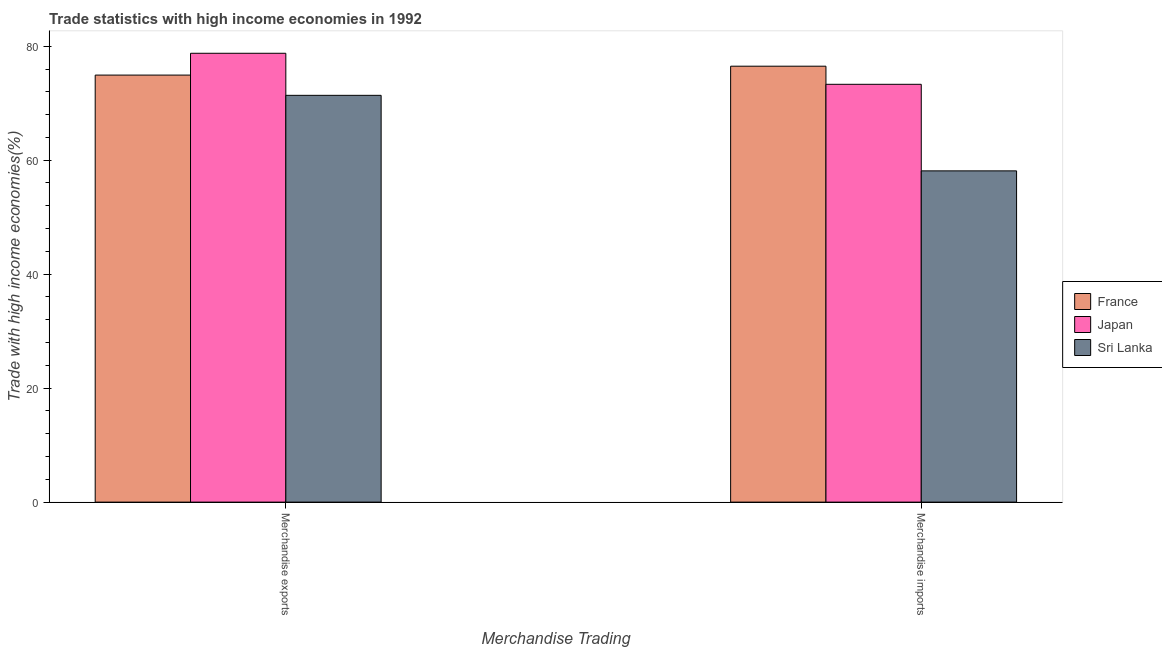How many groups of bars are there?
Offer a terse response. 2. Are the number of bars per tick equal to the number of legend labels?
Offer a very short reply. Yes. Are the number of bars on each tick of the X-axis equal?
Make the answer very short. Yes. How many bars are there on the 2nd tick from the left?
Provide a succinct answer. 3. How many bars are there on the 2nd tick from the right?
Provide a succinct answer. 3. What is the merchandise imports in France?
Provide a succinct answer. 76.49. Across all countries, what is the maximum merchandise exports?
Offer a terse response. 78.76. Across all countries, what is the minimum merchandise imports?
Your response must be concise. 58.13. In which country was the merchandise exports maximum?
Provide a short and direct response. Japan. In which country was the merchandise imports minimum?
Provide a short and direct response. Sri Lanka. What is the total merchandise exports in the graph?
Your response must be concise. 225.07. What is the difference between the merchandise imports in Japan and that in France?
Your answer should be compact. -3.18. What is the difference between the merchandise imports in Sri Lanka and the merchandise exports in France?
Give a very brief answer. -16.81. What is the average merchandise imports per country?
Provide a short and direct response. 69.31. What is the difference between the merchandise exports and merchandise imports in France?
Offer a terse response. -1.56. What is the ratio of the merchandise exports in Sri Lanka to that in France?
Your answer should be very brief. 0.95. Is the merchandise imports in France less than that in Japan?
Your answer should be very brief. No. What does the 3rd bar from the left in Merchandise imports represents?
Ensure brevity in your answer.  Sri Lanka. What does the 3rd bar from the right in Merchandise exports represents?
Keep it short and to the point. France. Are the values on the major ticks of Y-axis written in scientific E-notation?
Offer a very short reply. No. How many legend labels are there?
Provide a succinct answer. 3. What is the title of the graph?
Provide a succinct answer. Trade statistics with high income economies in 1992. What is the label or title of the X-axis?
Keep it short and to the point. Merchandise Trading. What is the label or title of the Y-axis?
Offer a terse response. Trade with high income economies(%). What is the Trade with high income economies(%) of France in Merchandise exports?
Keep it short and to the point. 74.93. What is the Trade with high income economies(%) of Japan in Merchandise exports?
Provide a succinct answer. 78.76. What is the Trade with high income economies(%) in Sri Lanka in Merchandise exports?
Give a very brief answer. 71.38. What is the Trade with high income economies(%) in France in Merchandise imports?
Provide a succinct answer. 76.49. What is the Trade with high income economies(%) of Japan in Merchandise imports?
Keep it short and to the point. 73.31. What is the Trade with high income economies(%) in Sri Lanka in Merchandise imports?
Offer a terse response. 58.13. Across all Merchandise Trading, what is the maximum Trade with high income economies(%) of France?
Make the answer very short. 76.49. Across all Merchandise Trading, what is the maximum Trade with high income economies(%) in Japan?
Provide a short and direct response. 78.76. Across all Merchandise Trading, what is the maximum Trade with high income economies(%) of Sri Lanka?
Provide a succinct answer. 71.38. Across all Merchandise Trading, what is the minimum Trade with high income economies(%) of France?
Provide a succinct answer. 74.93. Across all Merchandise Trading, what is the minimum Trade with high income economies(%) in Japan?
Make the answer very short. 73.31. Across all Merchandise Trading, what is the minimum Trade with high income economies(%) of Sri Lanka?
Keep it short and to the point. 58.13. What is the total Trade with high income economies(%) of France in the graph?
Your answer should be compact. 151.42. What is the total Trade with high income economies(%) of Japan in the graph?
Keep it short and to the point. 152.07. What is the total Trade with high income economies(%) of Sri Lanka in the graph?
Give a very brief answer. 129.5. What is the difference between the Trade with high income economies(%) of France in Merchandise exports and that in Merchandise imports?
Your answer should be very brief. -1.56. What is the difference between the Trade with high income economies(%) of Japan in Merchandise exports and that in Merchandise imports?
Ensure brevity in your answer.  5.45. What is the difference between the Trade with high income economies(%) in Sri Lanka in Merchandise exports and that in Merchandise imports?
Keep it short and to the point. 13.25. What is the difference between the Trade with high income economies(%) in France in Merchandise exports and the Trade with high income economies(%) in Japan in Merchandise imports?
Provide a short and direct response. 1.62. What is the difference between the Trade with high income economies(%) in France in Merchandise exports and the Trade with high income economies(%) in Sri Lanka in Merchandise imports?
Give a very brief answer. 16.81. What is the difference between the Trade with high income economies(%) in Japan in Merchandise exports and the Trade with high income economies(%) in Sri Lanka in Merchandise imports?
Provide a succinct answer. 20.64. What is the average Trade with high income economies(%) of France per Merchandise Trading?
Your response must be concise. 75.71. What is the average Trade with high income economies(%) in Japan per Merchandise Trading?
Your answer should be compact. 76.04. What is the average Trade with high income economies(%) in Sri Lanka per Merchandise Trading?
Keep it short and to the point. 64.75. What is the difference between the Trade with high income economies(%) of France and Trade with high income economies(%) of Japan in Merchandise exports?
Provide a short and direct response. -3.83. What is the difference between the Trade with high income economies(%) of France and Trade with high income economies(%) of Sri Lanka in Merchandise exports?
Keep it short and to the point. 3.55. What is the difference between the Trade with high income economies(%) of Japan and Trade with high income economies(%) of Sri Lanka in Merchandise exports?
Give a very brief answer. 7.38. What is the difference between the Trade with high income economies(%) of France and Trade with high income economies(%) of Japan in Merchandise imports?
Your response must be concise. 3.18. What is the difference between the Trade with high income economies(%) in France and Trade with high income economies(%) in Sri Lanka in Merchandise imports?
Make the answer very short. 18.37. What is the difference between the Trade with high income economies(%) in Japan and Trade with high income economies(%) in Sri Lanka in Merchandise imports?
Offer a very short reply. 15.19. What is the ratio of the Trade with high income economies(%) in France in Merchandise exports to that in Merchandise imports?
Your answer should be compact. 0.98. What is the ratio of the Trade with high income economies(%) of Japan in Merchandise exports to that in Merchandise imports?
Give a very brief answer. 1.07. What is the ratio of the Trade with high income economies(%) of Sri Lanka in Merchandise exports to that in Merchandise imports?
Your response must be concise. 1.23. What is the difference between the highest and the second highest Trade with high income economies(%) in France?
Offer a terse response. 1.56. What is the difference between the highest and the second highest Trade with high income economies(%) of Japan?
Ensure brevity in your answer.  5.45. What is the difference between the highest and the second highest Trade with high income economies(%) of Sri Lanka?
Give a very brief answer. 13.25. What is the difference between the highest and the lowest Trade with high income economies(%) of France?
Offer a terse response. 1.56. What is the difference between the highest and the lowest Trade with high income economies(%) of Japan?
Provide a short and direct response. 5.45. What is the difference between the highest and the lowest Trade with high income economies(%) in Sri Lanka?
Your response must be concise. 13.25. 